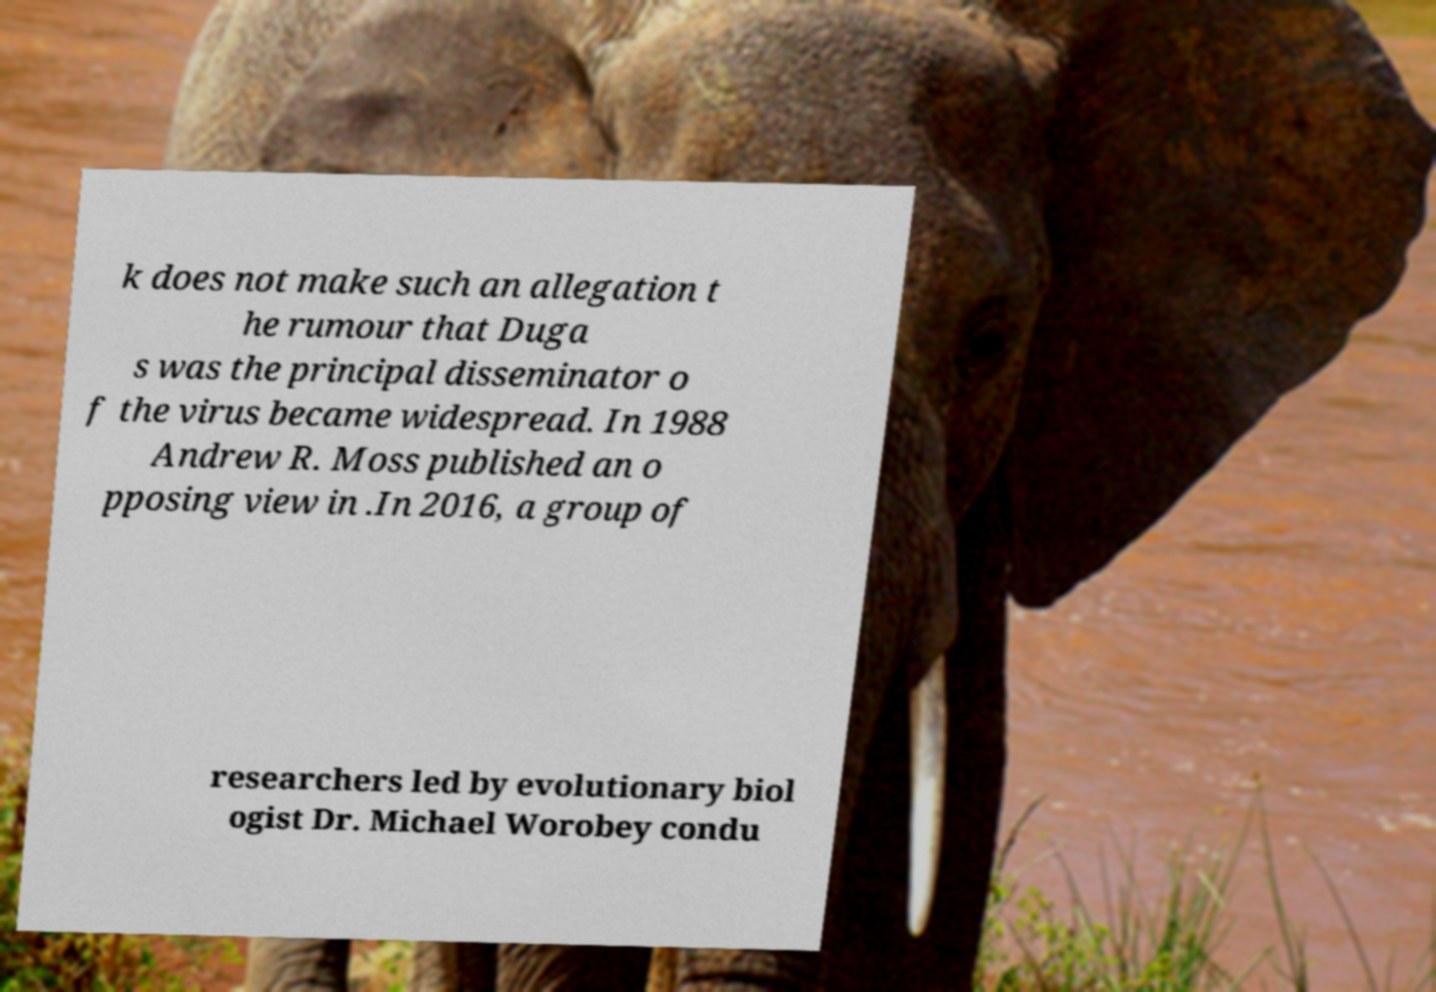There's text embedded in this image that I need extracted. Can you transcribe it verbatim? k does not make such an allegation t he rumour that Duga s was the principal disseminator o f the virus became widespread. In 1988 Andrew R. Moss published an o pposing view in .In 2016, a group of researchers led by evolutionary biol ogist Dr. Michael Worobey condu 